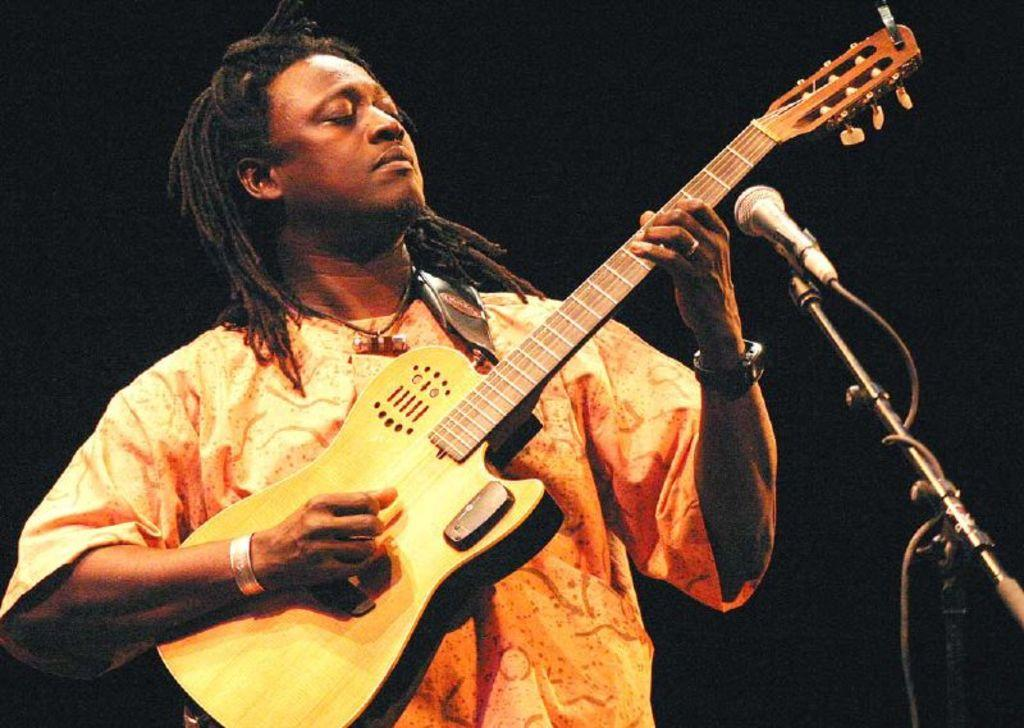What is the main subject of the image? There is a person in the image. What is the person doing in the image? The person is playing a guitar. What object is present in the image that is commonly used for amplifying sound? There is a microphone in the image. What is the value of the hope that can be seen in the image? There is no object or concept in the image that can be associated with a value or hope. 